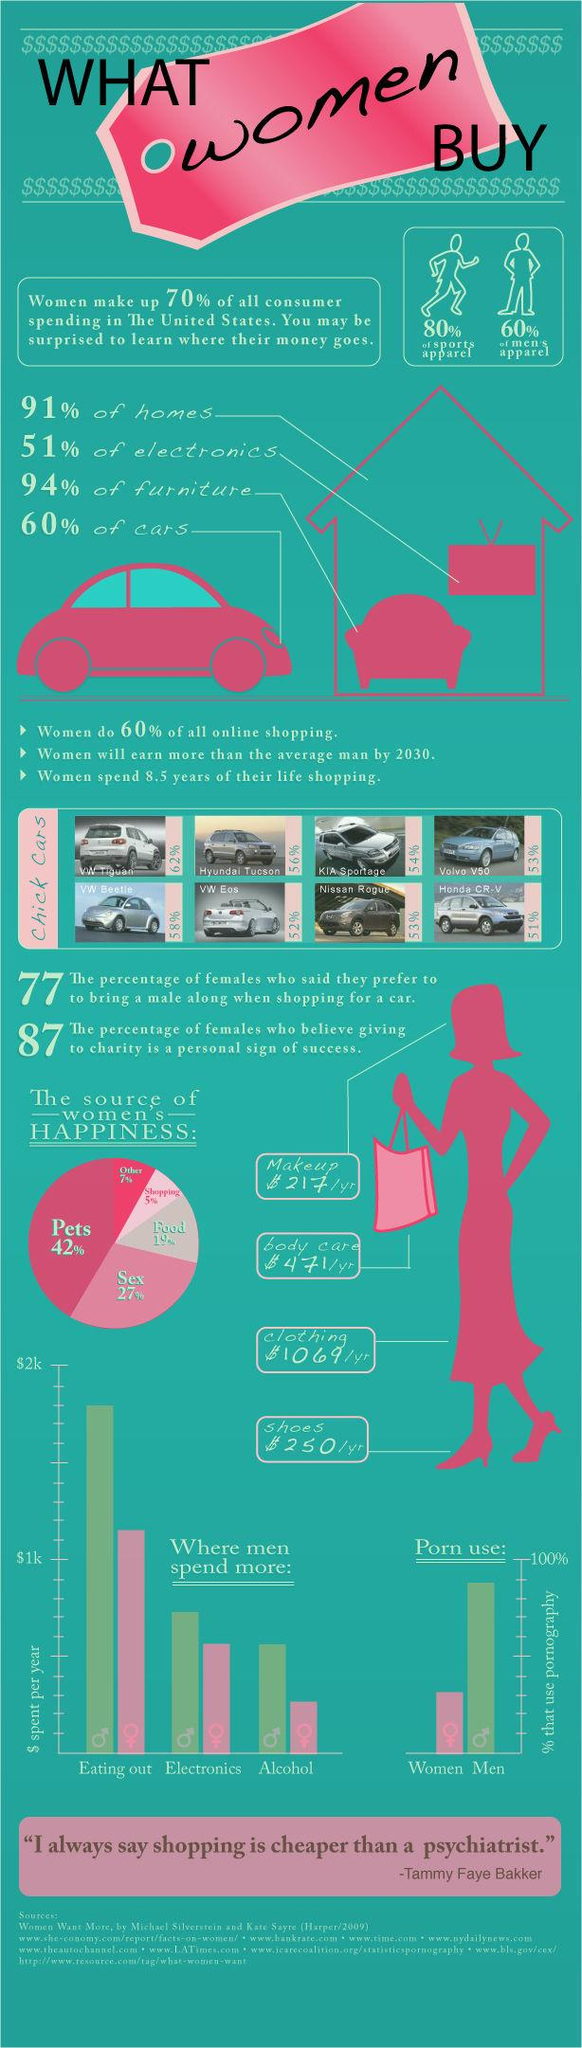Give some essential details in this illustration. According to a significant portion of women in the United States, pets are the primary source of happiness in their lives. According to a recent survey, only 5% of women in the United States reported feeling happy as a result of shopping. According to recent statistics, the amount of money spent on body care by women in the United States is approximately $471 per year. 